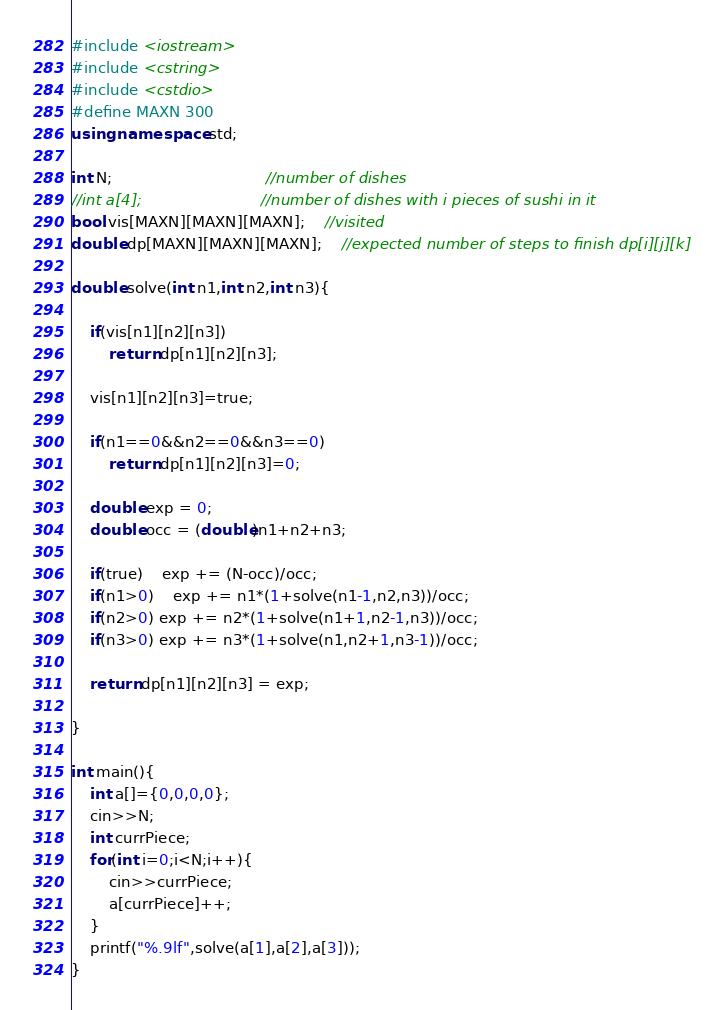Convert code to text. <code><loc_0><loc_0><loc_500><loc_500><_C++_>#include <iostream>
#include <cstring>
#include <cstdio>
#define MAXN 300
using namespace std;

int N;								//number of dishes 
//int a[4];							//number of dishes with i pieces of sushi in it
bool vis[MAXN][MAXN][MAXN];	//visited
double dp[MAXN][MAXN][MAXN];	//expected number of steps to finish dp[i][j][k]

double solve(int n1,int n2,int n3){
	
	if(vis[n1][n2][n3])
		return dp[n1][n2][n3];
	
	vis[n1][n2][n3]=true;
	
	if(n1==0&&n2==0&&n3==0)
		return dp[n1][n2][n3]=0;

	double exp = 0;
	double occ = (double)n1+n2+n3;

	if(true)	exp += (N-occ)/occ;
	if(n1>0)	exp += n1*(1+solve(n1-1,n2,n3))/occ;
	if(n2>0) exp += n2*(1+solve(n1+1,n2-1,n3))/occ;
	if(n3>0) exp += n3*(1+solve(n1,n2+1,n3-1))/occ;

	return dp[n1][n2][n3] = exp;

}

int main(){
 	int a[]={0,0,0,0};
	cin>>N;
	int currPiece;
	for(int i=0;i<N;i++){
		cin>>currPiece;
		a[currPiece]++;
	}
	printf("%.9lf",solve(a[1],a[2],a[3]));
}
</code> 